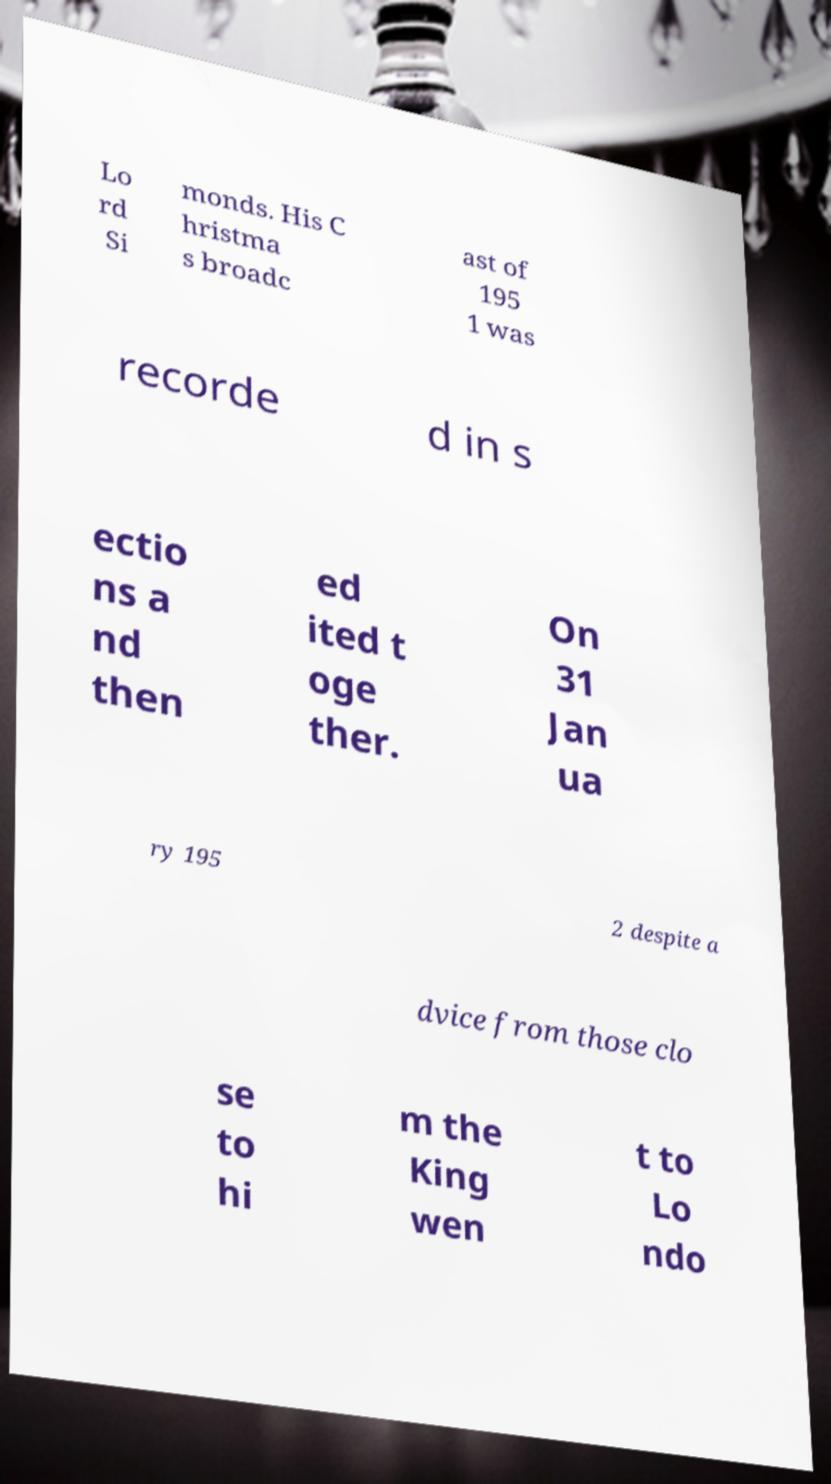Please read and relay the text visible in this image. What does it say? Lo rd Si monds. His C hristma s broadc ast of 195 1 was recorde d in s ectio ns a nd then ed ited t oge ther. On 31 Jan ua ry 195 2 despite a dvice from those clo se to hi m the King wen t to Lo ndo 